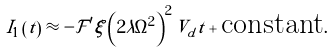<formula> <loc_0><loc_0><loc_500><loc_500>I _ { 1 } \left ( t \right ) \approx - \mathcal { F } ^ { \prime } \xi \left ( 2 \lambda \Omega ^ { 2 } \right ) ^ { 2 } V _ { d } t + \text {constant} .</formula> 